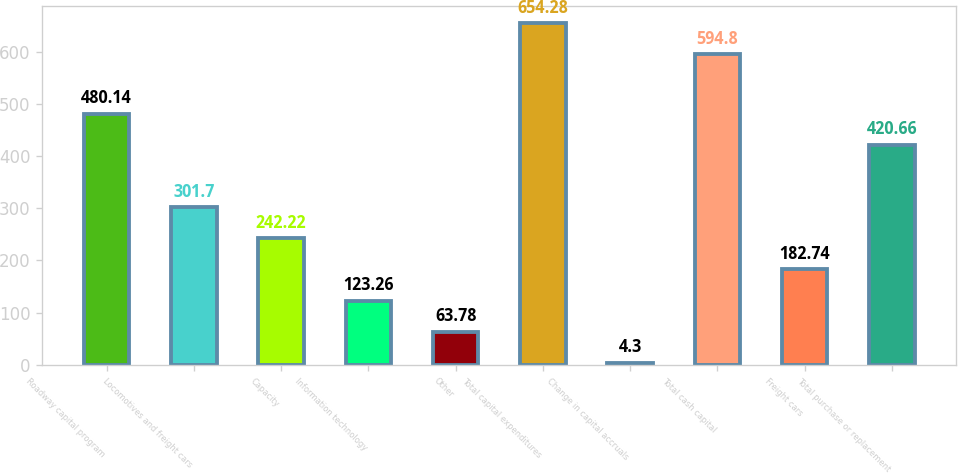Convert chart to OTSL. <chart><loc_0><loc_0><loc_500><loc_500><bar_chart><fcel>Roadway capital program<fcel>Locomotives and freight cars<fcel>Capacity<fcel>Information technology<fcel>Other<fcel>Total capital expenditures<fcel>Change in capital accruals<fcel>Total cash capital<fcel>Freight cars<fcel>Total purchase or replacement<nl><fcel>480.14<fcel>301.7<fcel>242.22<fcel>123.26<fcel>63.78<fcel>654.28<fcel>4.3<fcel>594.8<fcel>182.74<fcel>420.66<nl></chart> 